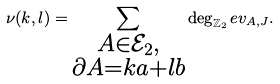<formula> <loc_0><loc_0><loc_500><loc_500>\nu ( k , l ) = \sum _ { \substack { A \in \mathcal { E } _ { 2 } , \\ \partial A = k a + l b } } \deg _ { \mathbb { Z } _ { 2 } } e v _ { A , J } .</formula> 